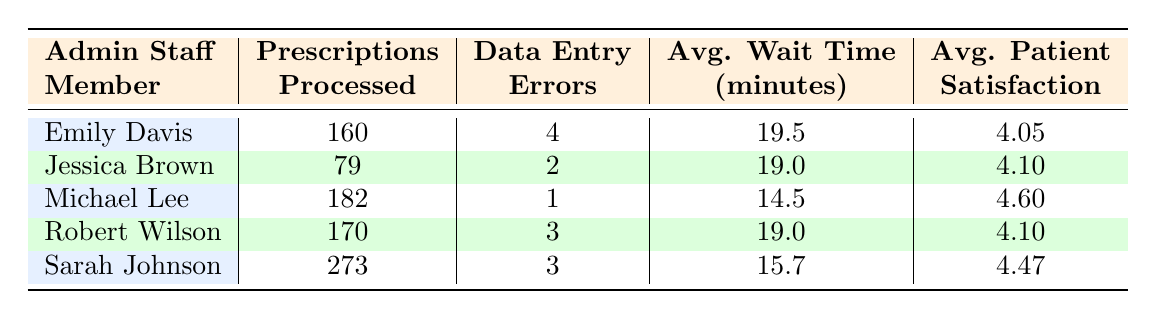What is the average patient satisfaction score for Emily Davis? Emily Davis's average patient satisfaction score can be found in the table, which shows a satisfaction score of 4.05.
Answer: 4.05 Which administrative staff member processed the most prescriptions? The table lists the total prescriptions processed for each staff member. Sarah Johnson processed 273 prescriptions, which is the highest.
Answer: Sarah Johnson What is the difference between the average patient wait times for Michael Lee and Sarah Johnson? Michael Lee's average wait time is 14.5 minutes, and Sarah Johnson's is 15.7 minutes. The difference is calculated as 15.7 - 14.5 = 1.2 minutes.
Answer: 1.2 minutes Did Robert Wilson make more data entry errors than Emily Davis? The table indicates that Robert Wilson made 3 data entry errors while Emily Davis made 4 errors. Therefore, the answer is no, Robert Wilson did not make more errors.
Answer: No What is the average patient satisfaction score for all administrative staff members combined? To find the average, add each staff member's satisfaction score: (4.05 + 4.10 + 4.60 + 4.10 + 4.47) = 20.32. There are 5 staff members, so divide 20.32 by 5 which equals 4.064.
Answer: 4.064 Which staff member had the lowest average patient satisfaction score? Looking at the satisfaction scores, Emily Davis has the lowest score of 4.05 compared to others: 4.10, 4.60, 4.10, and 4.47.
Answer: Emily Davis What is the average wait time for all staff members? To find the average wait time, sum the wait times (19.5 + 19.0 + 14.5 + 19.0 + 15.7) = 88.7 minutes. This is then divided by 5 staff members: 88.7 / 5 = 17.74 minutes.
Answer: 17.74 minutes Is the average patient wait time for Sarah Johnson less than the overall average wait time calculated? Sarah Johnson's average wait time is 15.7 minutes; the overall average wait time is 17.74 minutes. Since 15.7 is less than 17.74, the answer is yes.
Answer: Yes What percentage of data entry errors were made by Michael Lee compared to the total errors made? Michael Lee made 1 error. Total errors from all staff are (4+2+1+3+3=13). The percentage is (1 / 13) * 100 = 7.69%.
Answer: 7.69% 